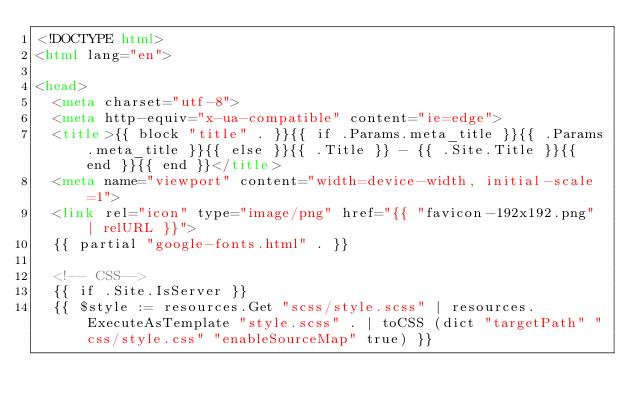Convert code to text. <code><loc_0><loc_0><loc_500><loc_500><_HTML_><!DOCTYPE html>
<html lang="en">

<head>
  <meta charset="utf-8">
  <meta http-equiv="x-ua-compatible" content="ie=edge">
  <title>{{ block "title" . }}{{ if .Params.meta_title }}{{ .Params.meta_title }}{{ else }}{{ .Title }} - {{ .Site.Title }}{{ end }}{{ end }}</title>
  <meta name="viewport" content="width=device-width, initial-scale=1">
  <link rel="icon" type="image/png" href="{{ "favicon-192x192.png" | relURL }}">
  {{ partial "google-fonts.html" . }}

  <!-- CSS-->
  {{ if .Site.IsServer }}
  {{ $style := resources.Get "scss/style.scss" | resources.ExecuteAsTemplate "style.scss" . | toCSS (dict "targetPath" "css/style.css" "enableSourceMap" true) }}</code> 